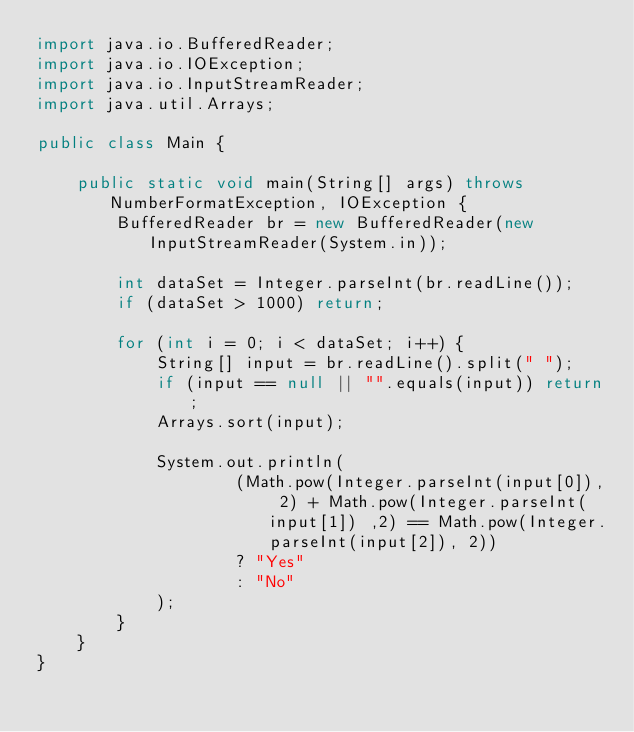Convert code to text. <code><loc_0><loc_0><loc_500><loc_500><_Java_>import java.io.BufferedReader;
import java.io.IOException;
import java.io.InputStreamReader;
import java.util.Arrays;

public class Main {

	public static void main(String[] args) throws NumberFormatException, IOException {
		BufferedReader br = new BufferedReader(new InputStreamReader(System.in));

		int dataSet = Integer.parseInt(br.readLine());
		if (dataSet > 1000) return;

		for (int i = 0; i < dataSet; i++) {
			String[] input = br.readLine().split(" ");
			if (input == null || "".equals(input)) return;
			Arrays.sort(input);

			System.out.println(
					(Math.pow(Integer.parseInt(input[0]), 2) + Math.pow(Integer.parseInt(input[1]) ,2) == Math.pow(Integer.parseInt(input[2]), 2))
					? "Yes"
					: "No"
			);
		}
	}
}</code> 